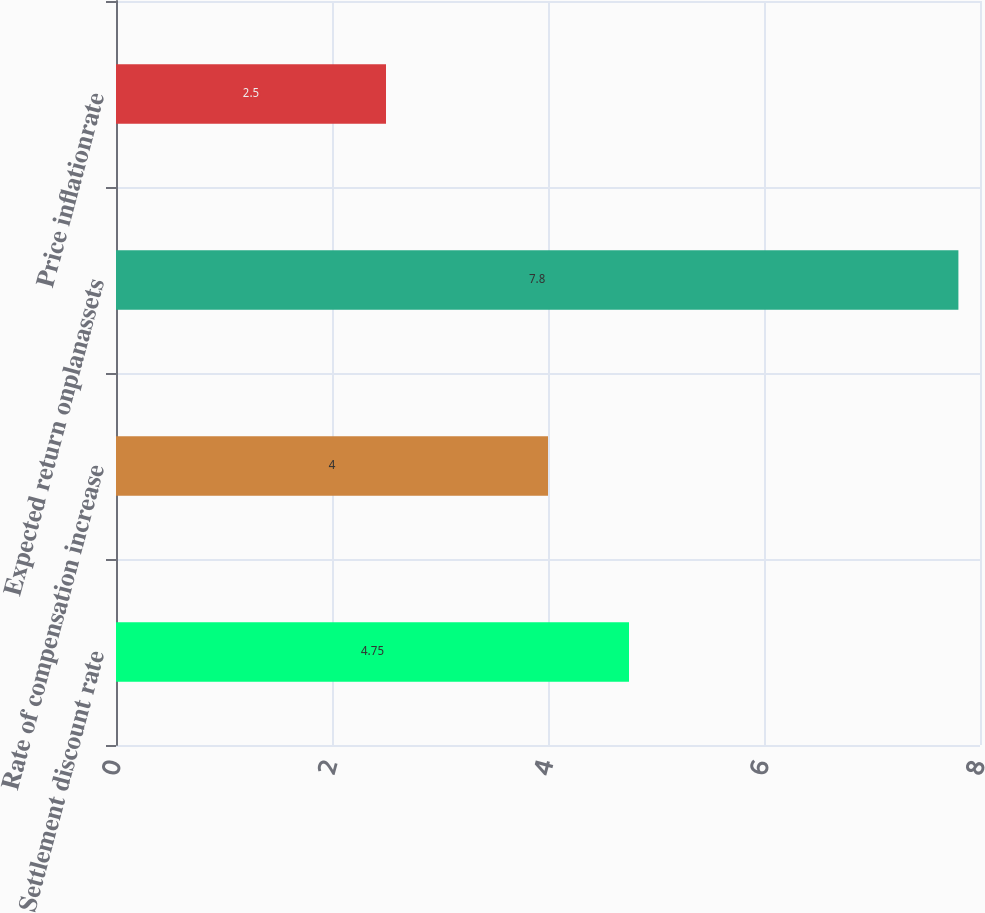Convert chart. <chart><loc_0><loc_0><loc_500><loc_500><bar_chart><fcel>Settlement discount rate<fcel>Rate of compensation increase<fcel>Expected return onplanassets<fcel>Price inflationrate<nl><fcel>4.75<fcel>4<fcel>7.8<fcel>2.5<nl></chart> 